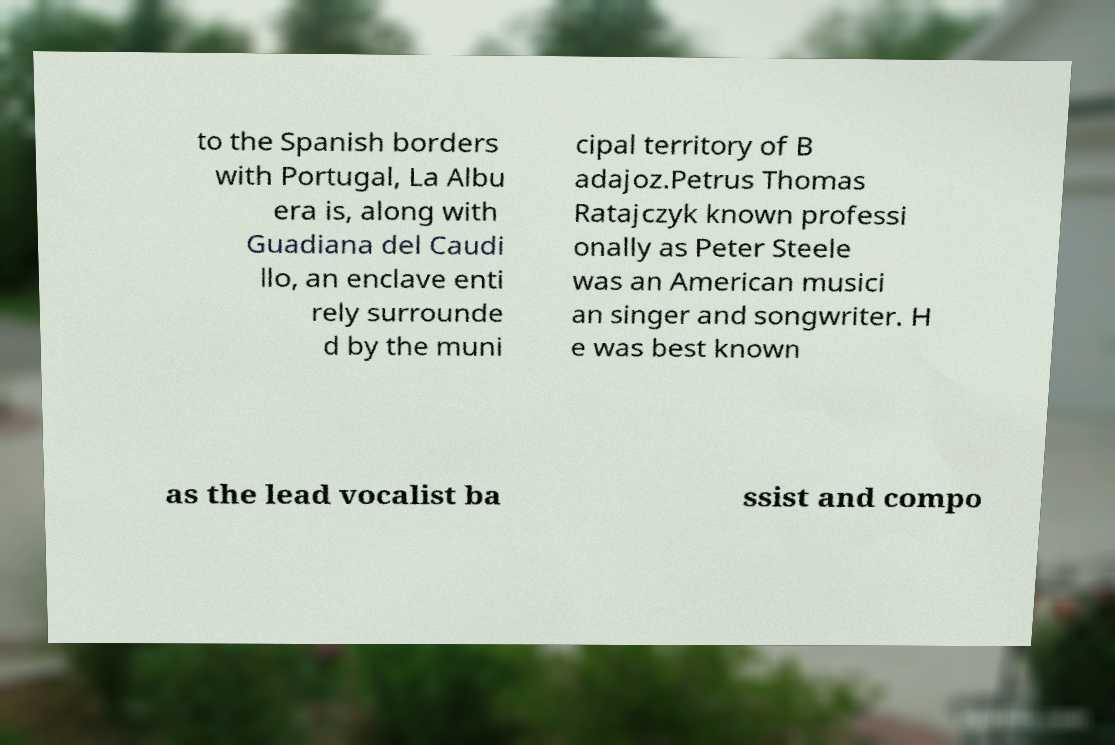Can you accurately transcribe the text from the provided image for me? to the Spanish borders with Portugal, La Albu era is, along with Guadiana del Caudi llo, an enclave enti rely surrounde d by the muni cipal territory of B adajoz.Petrus Thomas Ratajczyk known professi onally as Peter Steele was an American musici an singer and songwriter. H e was best known as the lead vocalist ba ssist and compo 